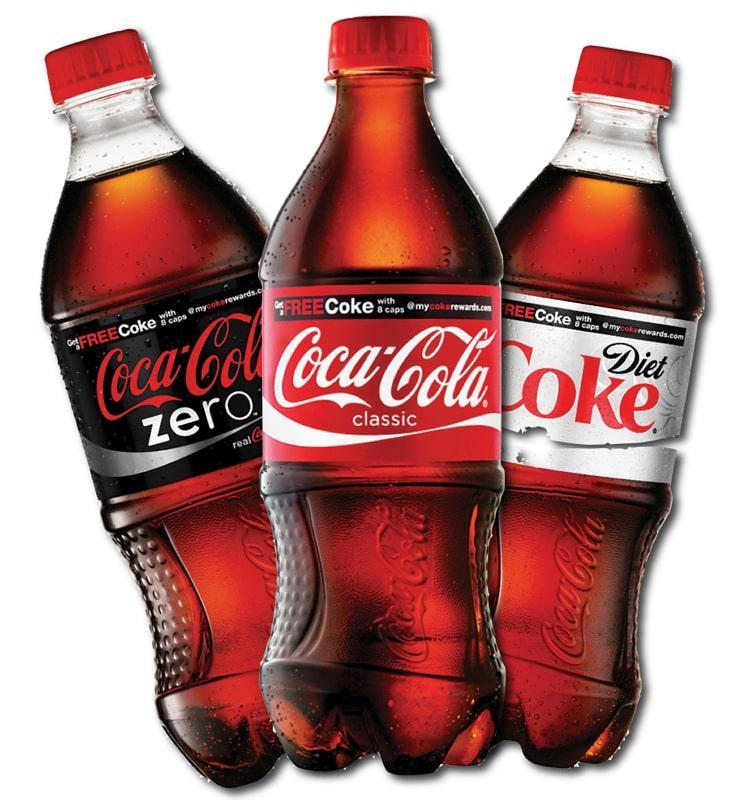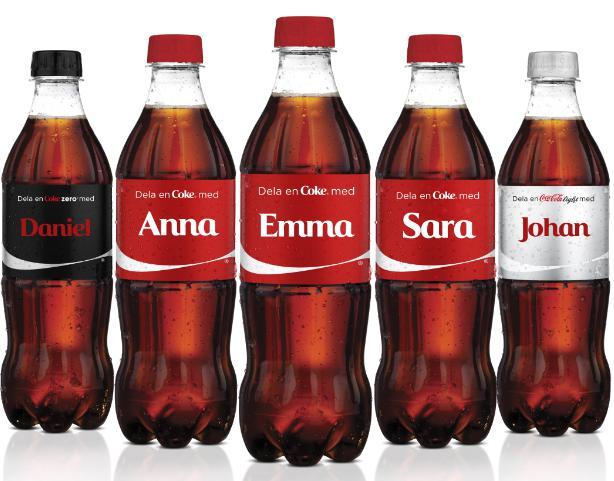The first image is the image on the left, the second image is the image on the right. For the images shown, is this caption "There are at most six bottles in the image pair." true? Answer yes or no. No. 